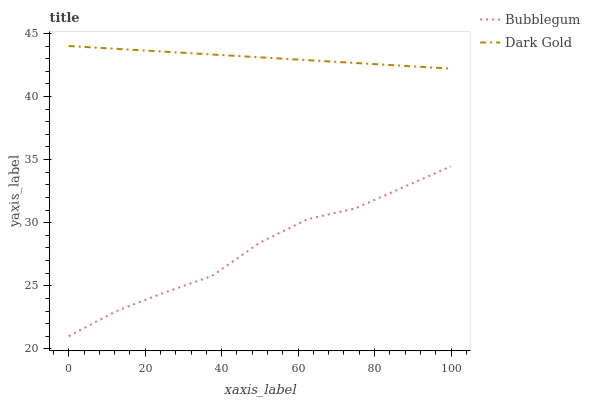Does Bubblegum have the minimum area under the curve?
Answer yes or no. Yes. Does Dark Gold have the maximum area under the curve?
Answer yes or no. Yes. Does Dark Gold have the minimum area under the curve?
Answer yes or no. No. Is Dark Gold the smoothest?
Answer yes or no. Yes. Is Bubblegum the roughest?
Answer yes or no. Yes. Is Dark Gold the roughest?
Answer yes or no. No. Does Bubblegum have the lowest value?
Answer yes or no. Yes. Does Dark Gold have the lowest value?
Answer yes or no. No. Does Dark Gold have the highest value?
Answer yes or no. Yes. Is Bubblegum less than Dark Gold?
Answer yes or no. Yes. Is Dark Gold greater than Bubblegum?
Answer yes or no. Yes. Does Bubblegum intersect Dark Gold?
Answer yes or no. No. 